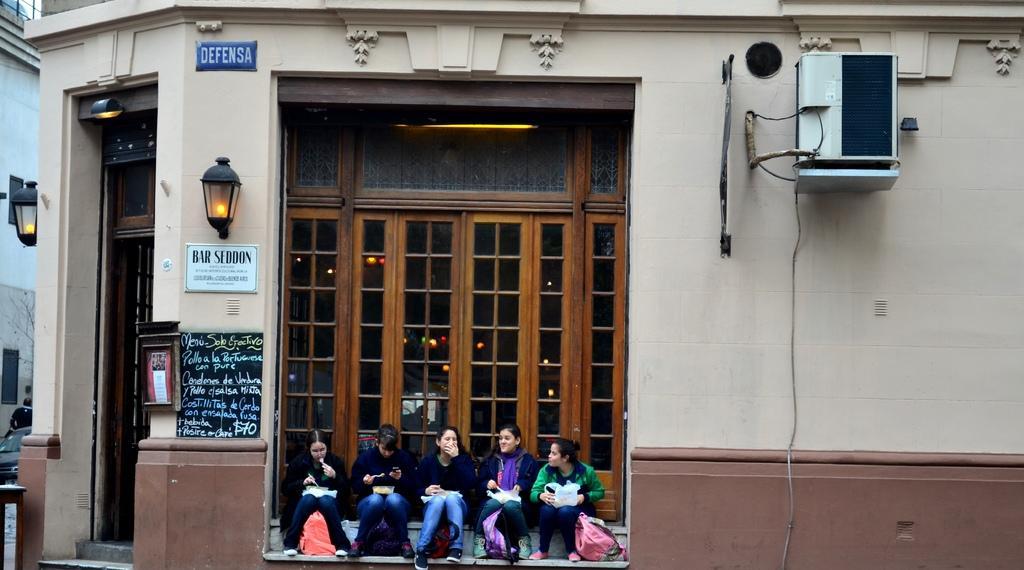Describe this image in one or two sentences. In this image there are few women are sitting before a door of a building. Few lamps are attached to the wall of the building. Woman wearing green jacket is holding bag in her hand. Beside her there is a bag on the floor. Left side there are two women having boxes on their laps. they are holding spoons in their hands. Left side there is a car. Behind there is a person. Behind there is a house. 